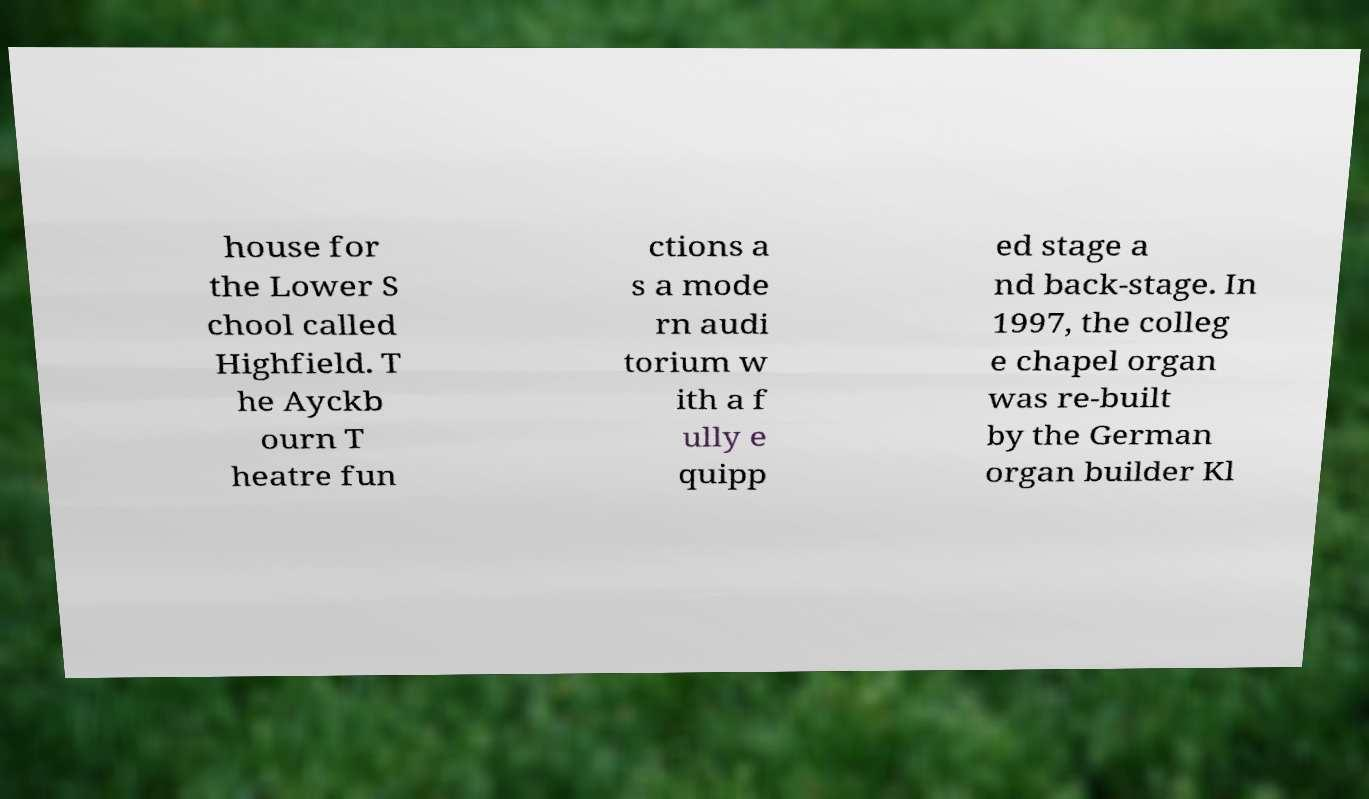Could you extract and type out the text from this image? house for the Lower S chool called Highfield. T he Ayckb ourn T heatre fun ctions a s a mode rn audi torium w ith a f ully e quipp ed stage a nd back-stage. In 1997, the colleg e chapel organ was re-built by the German organ builder Kl 